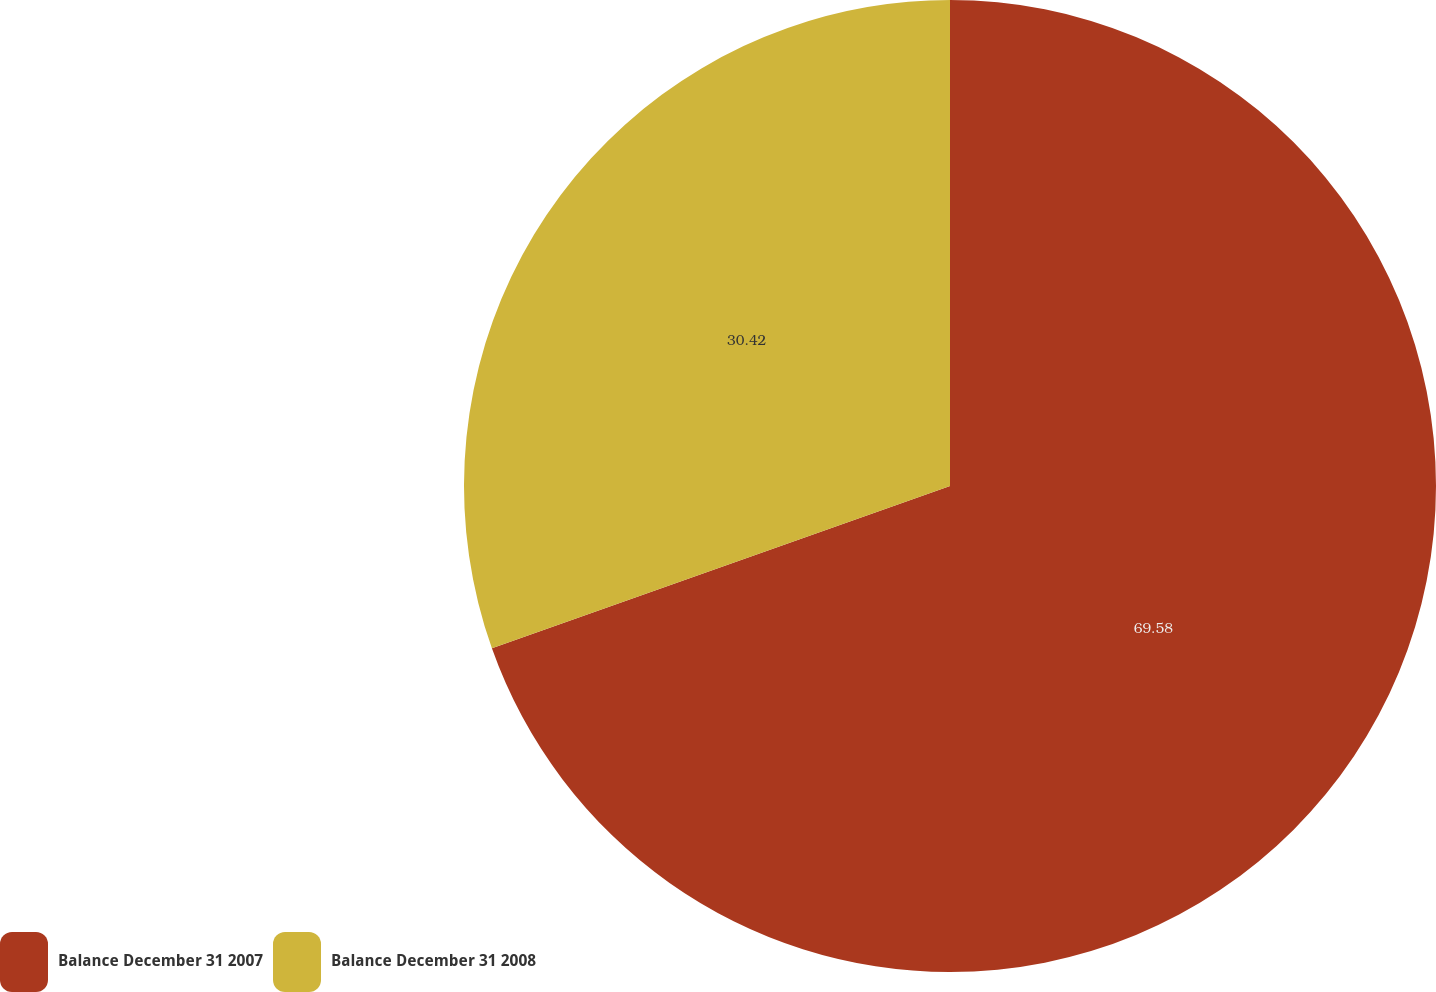Convert chart to OTSL. <chart><loc_0><loc_0><loc_500><loc_500><pie_chart><fcel>Balance December 31 2007<fcel>Balance December 31 2008<nl><fcel>69.58%<fcel>30.42%<nl></chart> 